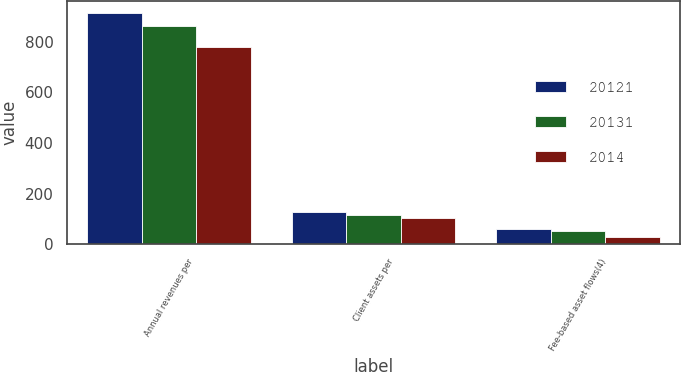Convert chart. <chart><loc_0><loc_0><loc_500><loc_500><stacked_bar_chart><ecel><fcel>Annual revenues per<fcel>Client assets per<fcel>Fee-based asset flows(4)<nl><fcel>20121<fcel>914<fcel>126<fcel>58.8<nl><fcel>20131<fcel>863<fcel>116<fcel>51.9<nl><fcel>2014<fcel>780<fcel>104<fcel>26.9<nl></chart> 